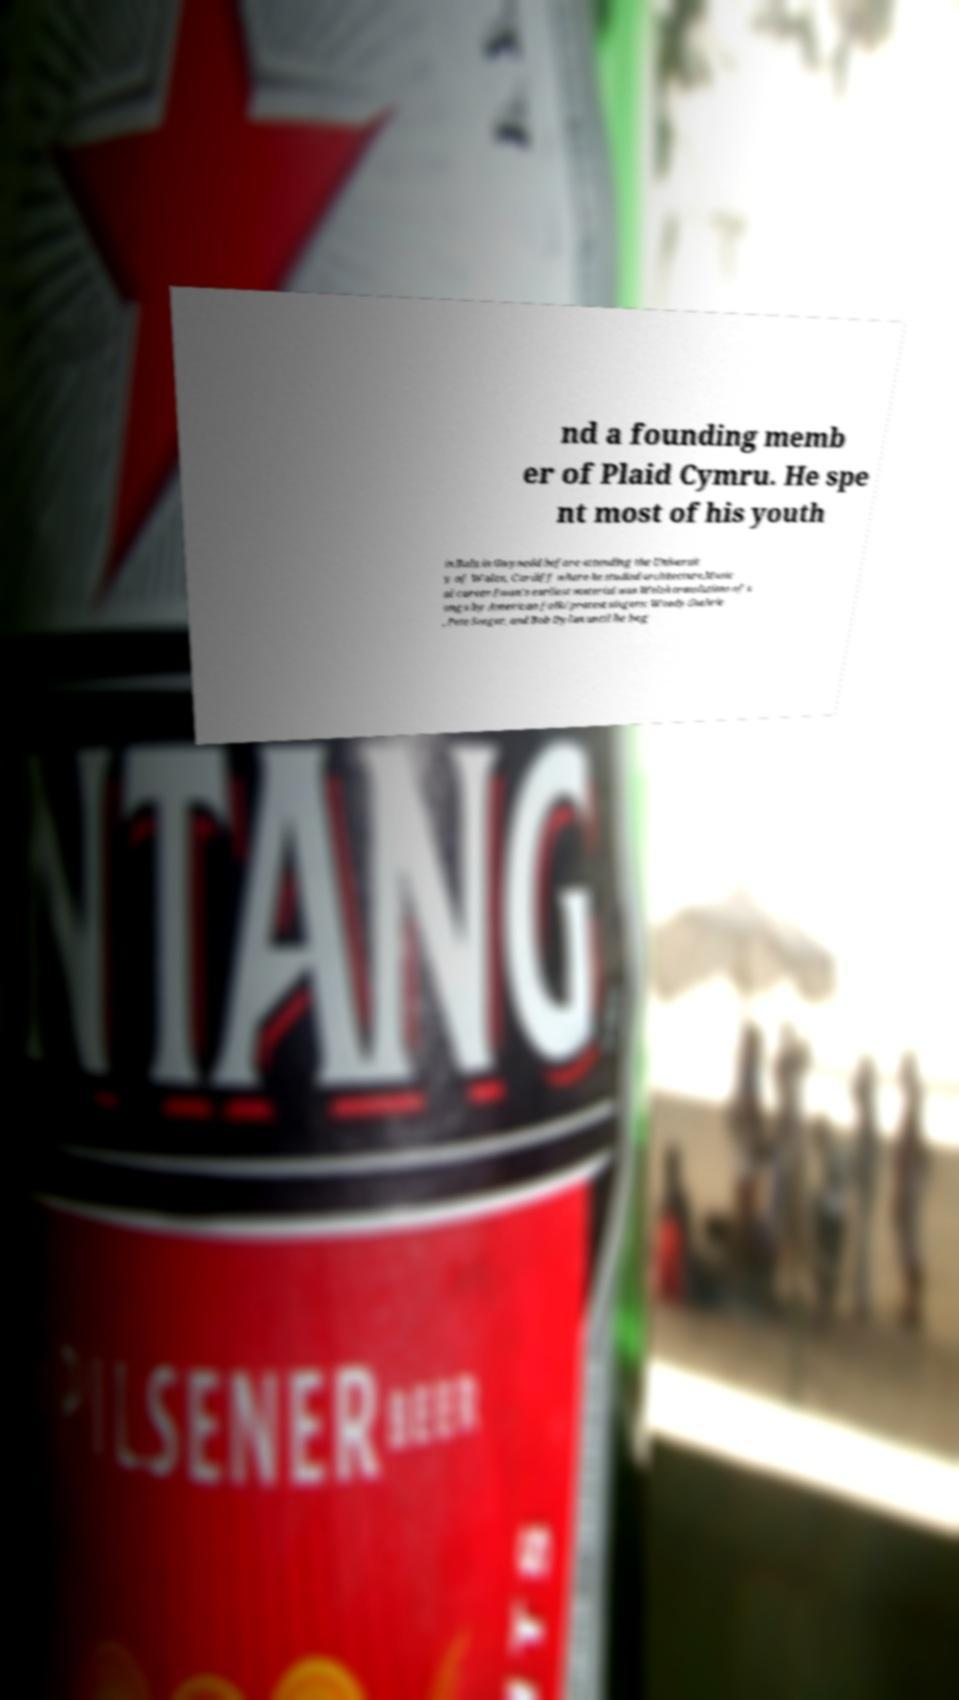What messages or text are displayed in this image? I need them in a readable, typed format. nd a founding memb er of Plaid Cymru. He spe nt most of his youth in Bala in Gwynedd before attending the Universit y of Wales, Cardiff where he studied architecture.Music al career.Iwan's earliest material was Welsh translations of s ongs by American folk/protest singers: Woody Guthrie , Pete Seeger, and Bob Dylan until he beg 